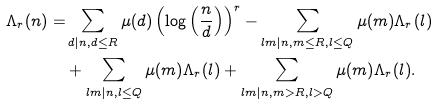Convert formula to latex. <formula><loc_0><loc_0><loc_500><loc_500>{ } \Lambda _ { r } ( n ) = & \sum _ { d | n , d \leq R } \mu ( d ) \left ( \log \left ( \frac { n } { d } \right ) \right ) ^ { r } - \sum _ { l m | n , m \leq R , l \leq Q } \mu ( m ) \Lambda _ { r } ( l ) \\ & + \sum _ { l m | n , l \leq Q } \mu ( m ) \Lambda _ { r } ( l ) + \sum _ { l m | n , m > R , l > Q } \mu ( m ) \Lambda _ { r } ( l ) .</formula> 